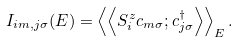<formula> <loc_0><loc_0><loc_500><loc_500>I _ { i m , j \sigma } ( E ) = \left < \left < S _ { i } ^ { z } c _ { m \sigma } ; c _ { j \sigma } ^ { \dag } \right > \right > _ { E } .</formula> 